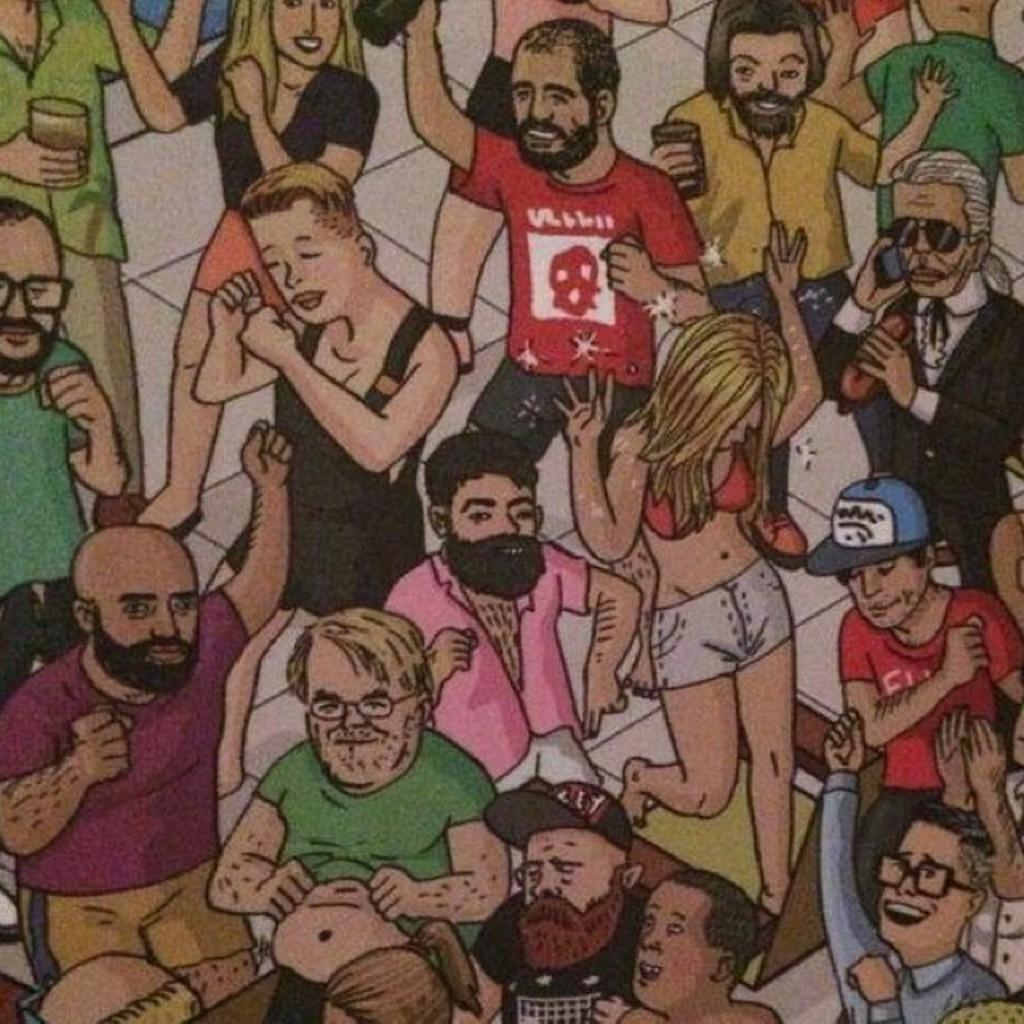What type of picture is in the image? The image contains an animated picture. What is happening in the animated picture? There are people in the animated picture, and they are dancing. Where are the people in the animated picture located? The people are on the floor in the animated picture. What type of wood can be seen in the image? There is no wood present in the image; it contains an animated picture with people dancing on the floor. 